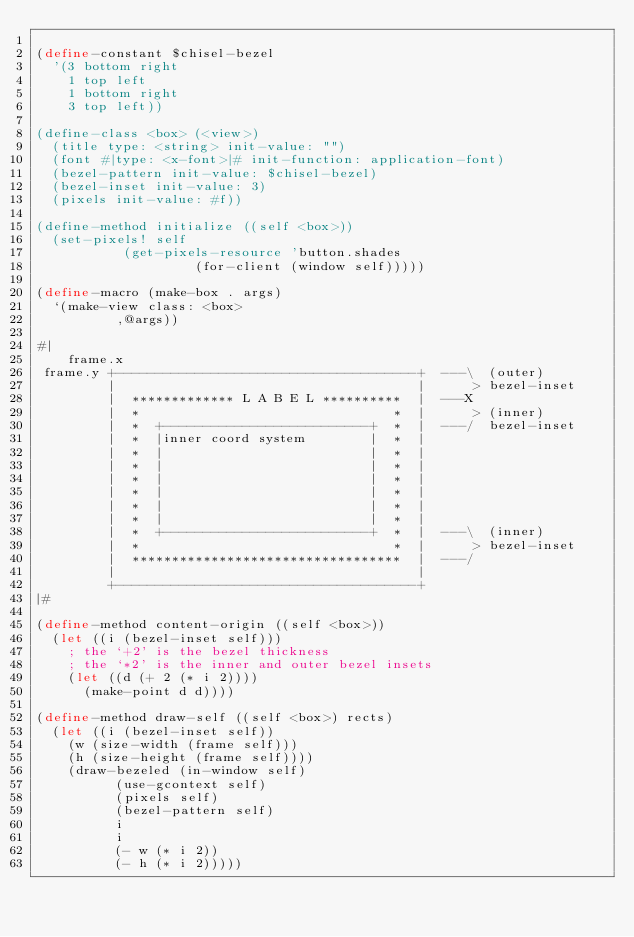<code> <loc_0><loc_0><loc_500><loc_500><_Scheme_>
(define-constant $chisel-bezel
  '(3 bottom right
    1 top left
    1 bottom right
    3 top left))

(define-class <box> (<view>)
  (title type: <string> init-value: "")
  (font #|type: <x-font>|# init-function: application-font)
  (bezel-pattern init-value: $chisel-bezel)
  (bezel-inset init-value: 3)
  (pixels init-value: #f))

(define-method initialize ((self <box>))
  (set-pixels! self
	       (get-pixels-resource 'button.shades
				    (for-client (window self)))))

(define-macro (make-box . args)
  `(make-view class: <box>
	      ,@args))

#|
	frame.x
 frame.y +--------------------------------------+  ---\	 (outer)
         |                                      |      > bezel-inset
         |  ************* L A B E L **********  |  ---X
         |  *                                *  |      > (inner)
         |  *  +--------------------------+  *  |  ---/	 bezel-inset
         |  *  |inner coord system        |  *  |
         |  *  |                          |  *  |
         |  *  |                          |  *  |
         |  *  |                          |  *  |
         |  *  |                          |  *  |
         |  *  |                          |  *  |
         |  *  |                          |  *  |
         |  *  +--------------------------+  *  |  ---\	 (inner)
         |  *                                *  |      > bezel-inset
         |  **********************************  |  ---/
         |                                      |
         +--------------------------------------+
|#

(define-method content-origin ((self <box>))
  (let ((i (bezel-inset self)))
    ; the `+2' is the bezel thickness
    ; the `*2' is the inner and outer bezel insets
    (let ((d (+ 2 (* i 2))))
      (make-point d d))))

(define-method draw-self ((self <box>) rects)
  (let ((i (bezel-inset self))
	(w (size-width (frame self)))
	(h (size-height (frame self))))
    (draw-bezeled (in-window self)
		  (use-gcontext self)
		  (pixels self)
		  (bezel-pattern self)
		  i
		  i
		  (- w (* i 2))
		  (- h (* i 2)))))



</code> 